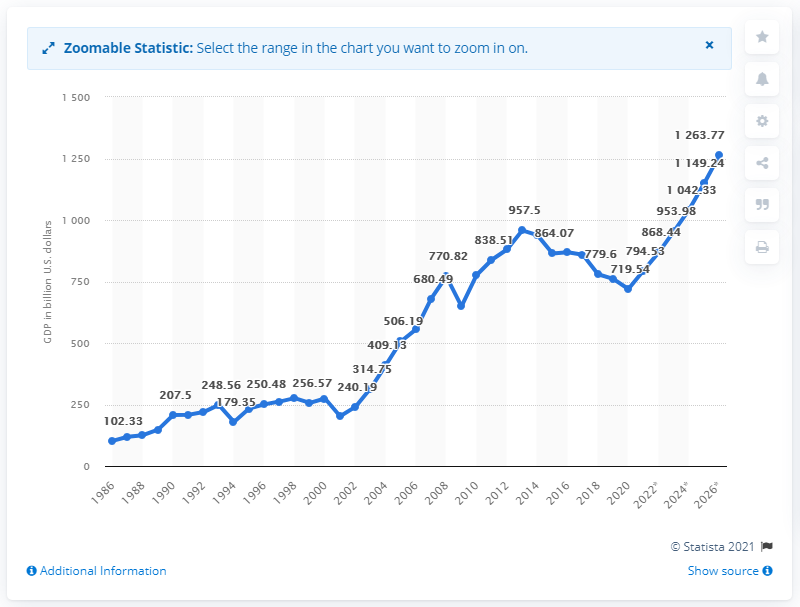Point out several critical features in this image. In 2020, Turkey's GDP was 719.54 billion dollars. 